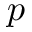<formula> <loc_0><loc_0><loc_500><loc_500>p</formula> 